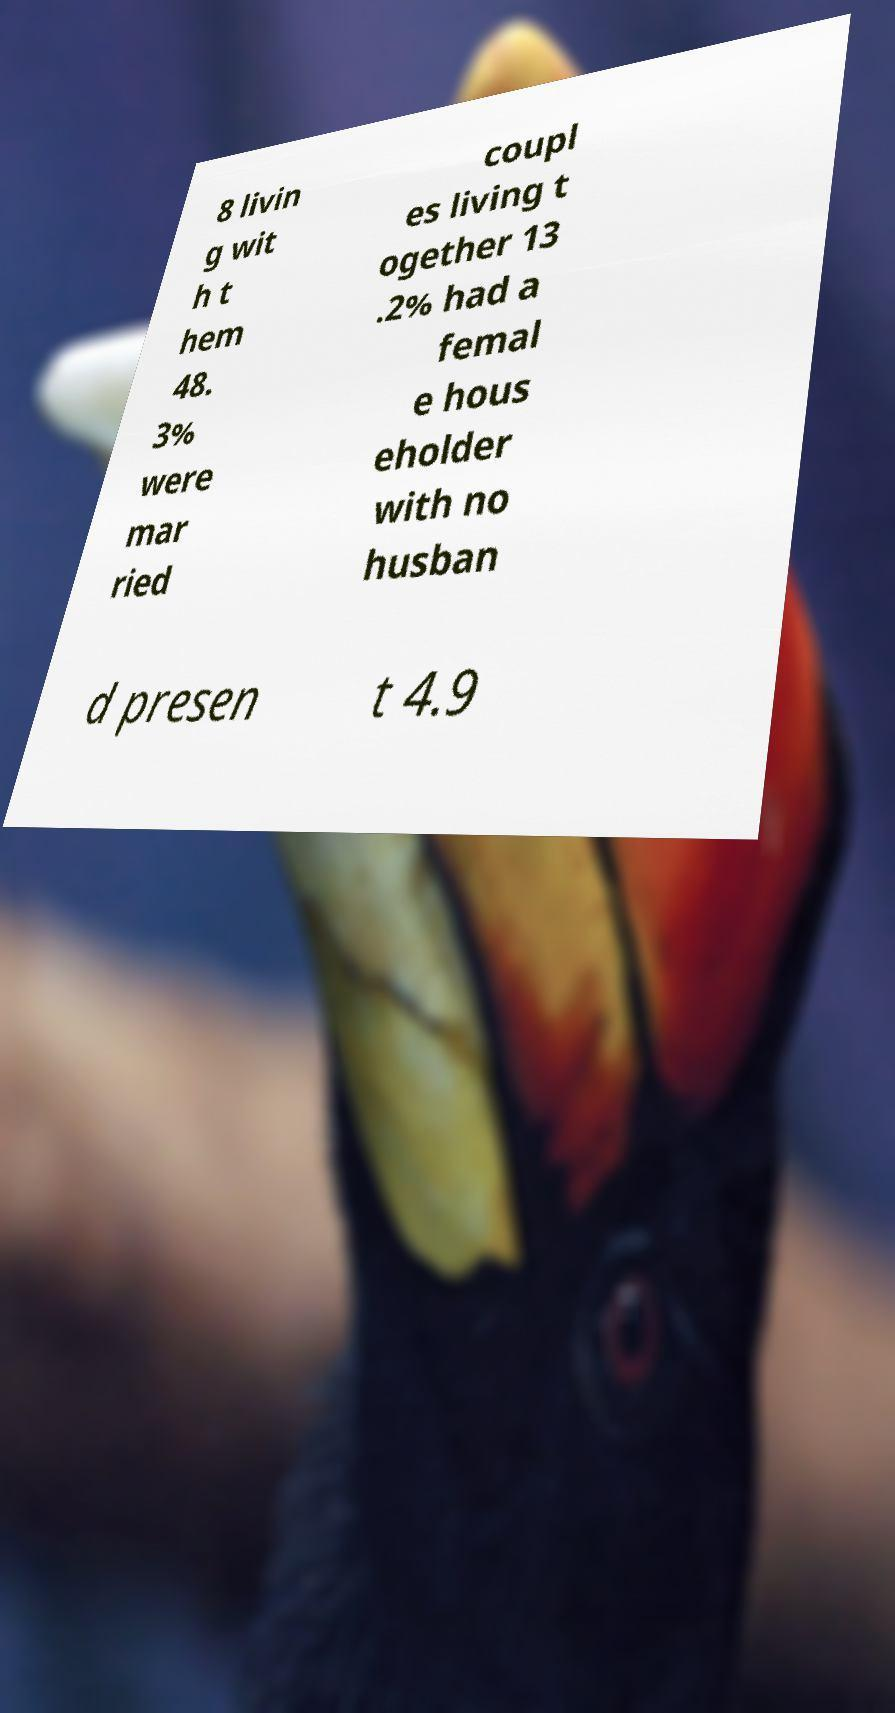Can you accurately transcribe the text from the provided image for me? 8 livin g wit h t hem 48. 3% were mar ried coupl es living t ogether 13 .2% had a femal e hous eholder with no husban d presen t 4.9 